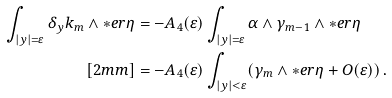Convert formula to latex. <formula><loc_0><loc_0><loc_500><loc_500>\int _ { | y | = \varepsilon } \delta _ { y } k _ { m } \wedge \ast e r \eta & = - A _ { 4 } ( \varepsilon ) \int _ { | y | = \varepsilon } \alpha \wedge \gamma _ { m - 1 } \wedge \ast e r \eta \\ [ 2 m m ] & = - A _ { 4 } ( \varepsilon ) \int _ { | y | < \varepsilon } ( \gamma _ { m } \wedge \ast e r \eta + O ( \varepsilon ) ) \, .</formula> 